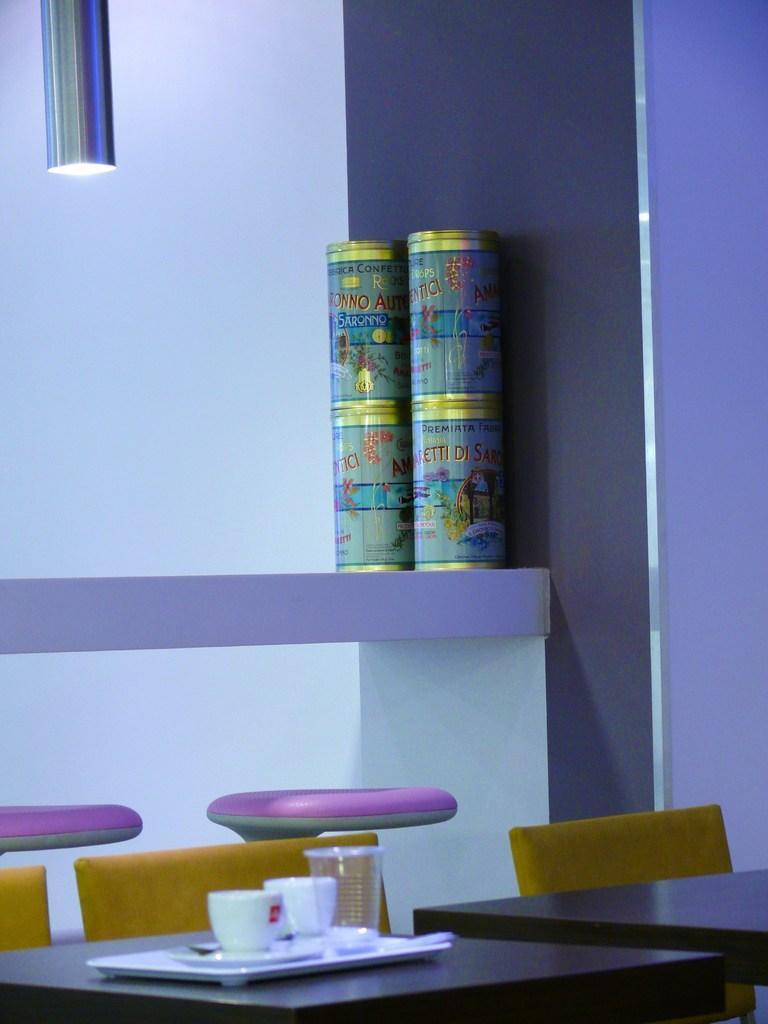Please provide a concise description of this image. In this image there is a rack, tables, chairs, light, wall, cups and objects. 